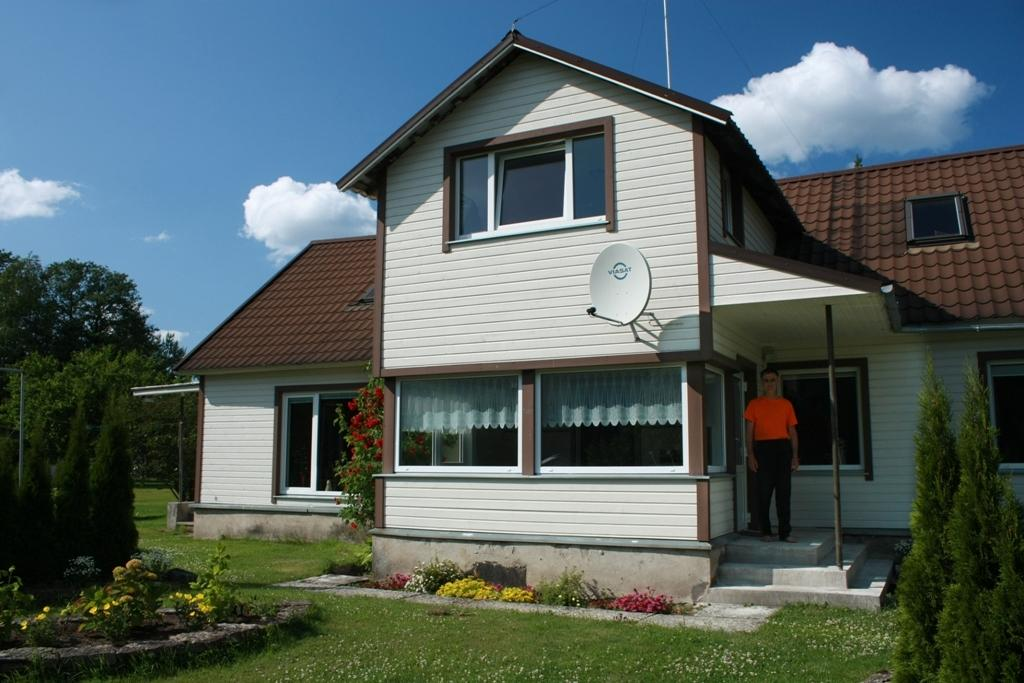What is the main subject of the image? There is a man standing in the image. Where is the man located in relation to the building? The man is standing under the building. What type of doors does the building have? The building has glass doors. What type of vegetation is around the building? There are trees and flower plants around the building. What type of soup is being served in the image? There is no soup present in the image. What type of crack is visible on the ground in the image? There is no crack visible on the ground in the image. 